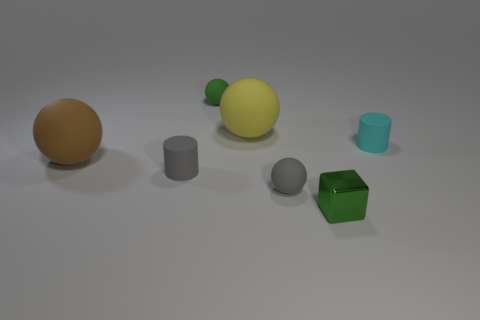What number of other objects are there of the same material as the big brown thing?
Keep it short and to the point. 5. There is a matte ball that is to the right of the tiny green ball and in front of the tiny cyan object; how big is it?
Make the answer very short. Small. What shape is the big rubber thing behind the large rubber object that is in front of the large yellow ball?
Ensure brevity in your answer.  Sphere. Are there any other things that have the same shape as the cyan object?
Provide a short and direct response. Yes. Are there an equal number of blocks that are in front of the small green metal block and small purple things?
Ensure brevity in your answer.  Yes. Does the metallic object have the same color as the small ball that is to the left of the large yellow sphere?
Give a very brief answer. Yes. What is the color of the rubber sphere that is in front of the big yellow object and right of the big brown object?
Keep it short and to the point. Gray. There is a tiny green thing that is on the left side of the small block; how many cylinders are in front of it?
Ensure brevity in your answer.  2. Are there any other things that have the same shape as the green matte thing?
Provide a succinct answer. Yes. There is a green object in front of the green matte thing; does it have the same shape as the cyan object behind the brown matte ball?
Offer a very short reply. No. 